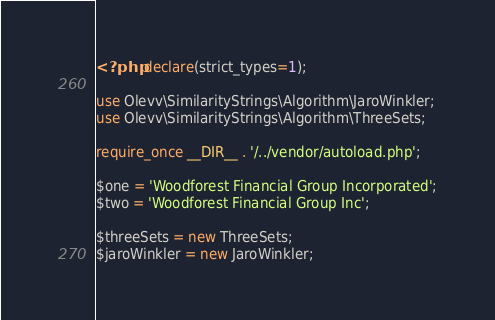Convert code to text. <code><loc_0><loc_0><loc_500><loc_500><_PHP_><?php declare(strict_types=1);

use Olevv\SimilarityStrings\Algorithm\JaroWinkler;
use Olevv\SimilarityStrings\Algorithm\ThreeSets;

require_once __DIR__ . '/../vendor/autoload.php';

$one = 'Woodforest Financial Group Incorporated';
$two = 'Woodforest Financial Group Inc';

$threeSets = new ThreeSets;
$jaroWinkler = new JaroWinkler;
</code> 